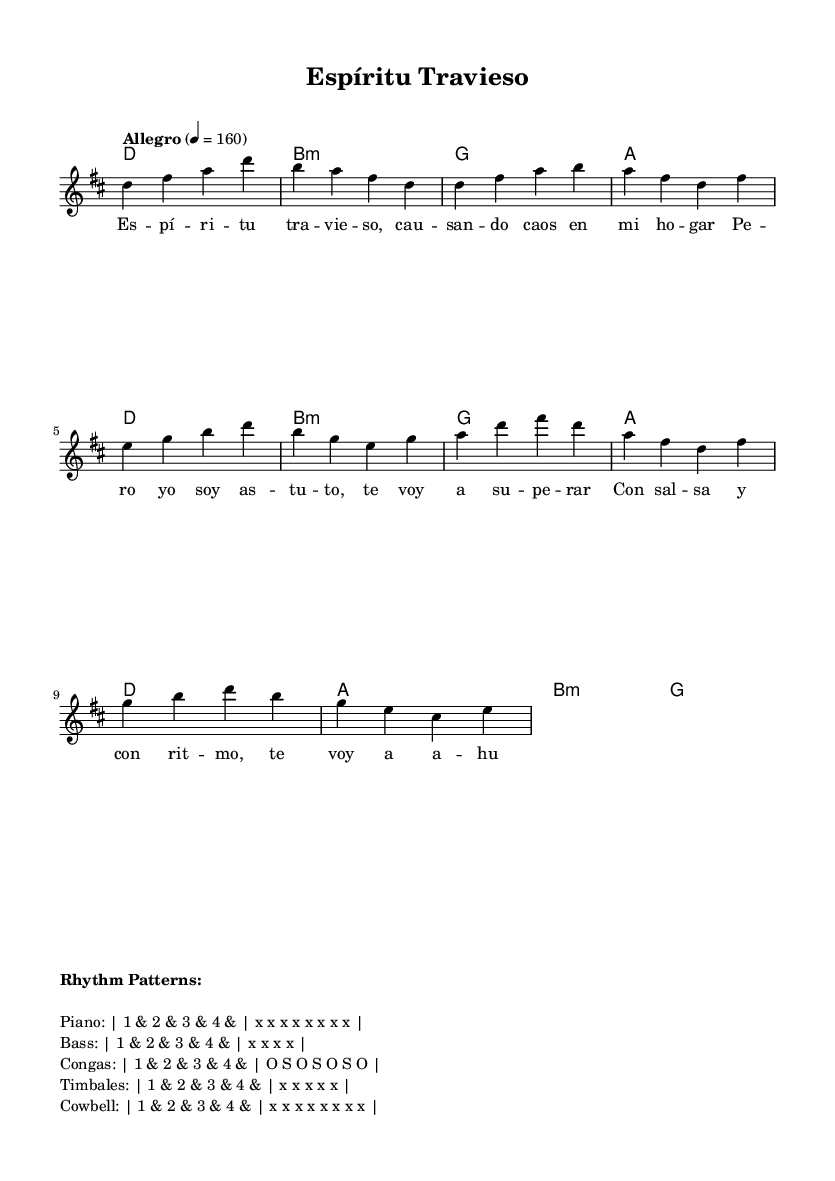What is the key signature of this music? The key signature is indicated at the beginning of the staff. It shows two sharps, F sharp and C sharp, which define the key of D major.
Answer: D major What is the time signature of this music? The time signature is placed at the beginning of the piece, showing a "4/4" symbol. This indicates that there are four beats in each measure.
Answer: 4/4 What is the tempo marking for this piece? The tempo marking is indicated in Italian terms at the start of the score. "Allegro" suggests a fast-paced character, and it is marked to be played at 160 beats per minute.
Answer: Allegro What is the main theme of the lyrics? The lyrics focus on outsmarting a troublesome spirit in the context of maintaining order in the home. The use of cleverness and rhythm is emphasized against chaos.
Answer: Outsmarting spirits Which instruments are indicated in the rhythm patterns? The rhythm patterns include multiple instruments listed specifically: Piano, Bass, Congas, Timbales, and Cowbell. Each has distinct rhythmic roles in the piece.
Answer: Piano, Bass, Congas, Timbales, Cowbell What are the first two chords used in the introduction? The first two chords are indicated in the harmonies section. The introduction starts with D major followed by B minor, providing a sense of the tonal environment.
Answer: D, B minor How is the chorus lyrical structure different from the verse? In the chorus, the lyrics are more repetitive and emphasize the resolution to maintain order, contrasting with the verse, which introduces the problem with the spirit.
Answer: More repetitive and resolution-focused 